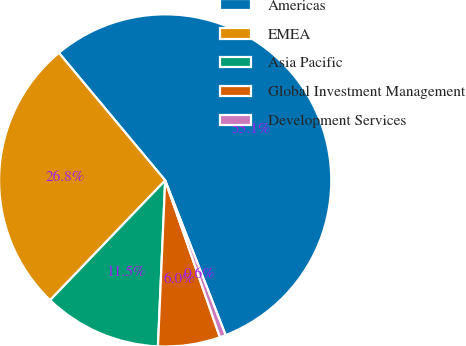Convert chart to OTSL. <chart><loc_0><loc_0><loc_500><loc_500><pie_chart><fcel>Americas<fcel>EMEA<fcel>Asia Pacific<fcel>Global Investment Management<fcel>Development Services<nl><fcel>55.13%<fcel>26.76%<fcel>11.49%<fcel>6.04%<fcel>0.58%<nl></chart> 